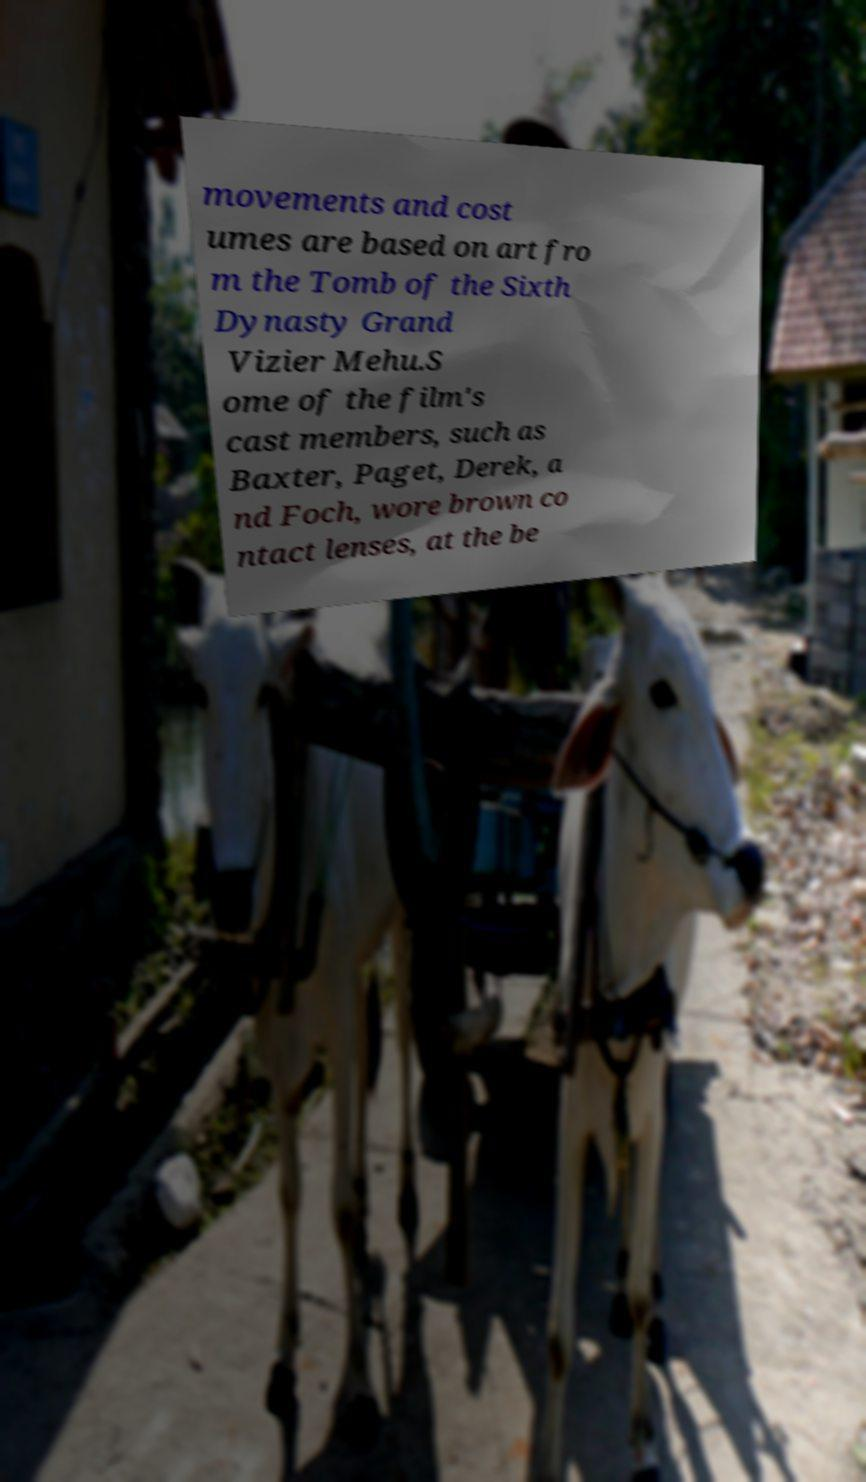For documentation purposes, I need the text within this image transcribed. Could you provide that? movements and cost umes are based on art fro m the Tomb of the Sixth Dynasty Grand Vizier Mehu.S ome of the film's cast members, such as Baxter, Paget, Derek, a nd Foch, wore brown co ntact lenses, at the be 